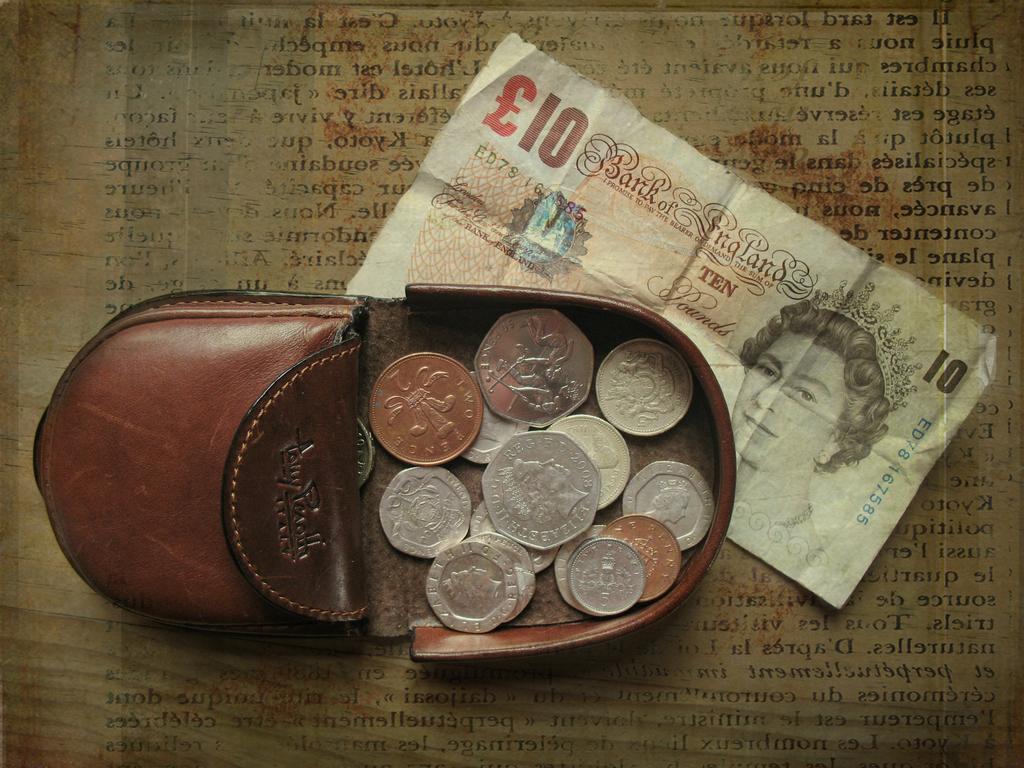What note is that?
Provide a short and direct response. 10. 